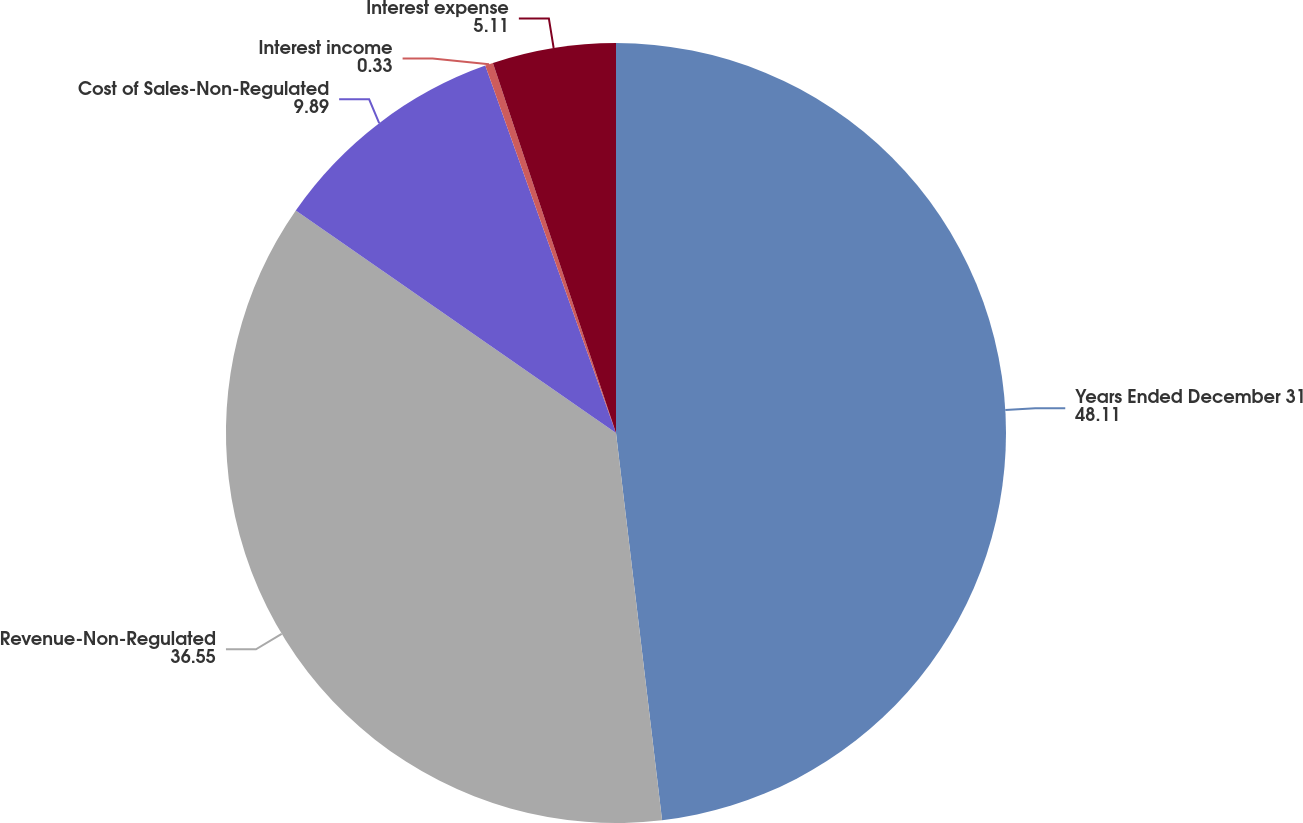Convert chart. <chart><loc_0><loc_0><loc_500><loc_500><pie_chart><fcel>Years Ended December 31<fcel>Revenue-Non-Regulated<fcel>Cost of Sales-Non-Regulated<fcel>Interest income<fcel>Interest expense<nl><fcel>48.11%<fcel>36.55%<fcel>9.89%<fcel>0.33%<fcel>5.11%<nl></chart> 